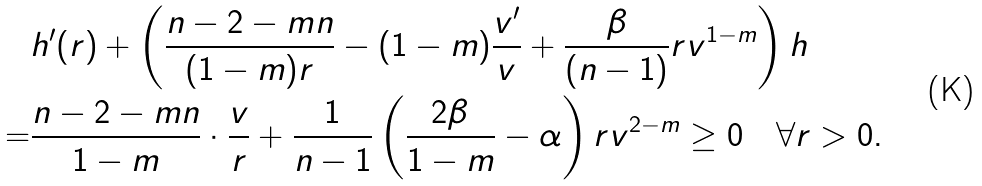<formula> <loc_0><loc_0><loc_500><loc_500>& h ^ { \prime } ( r ) + \left ( \frac { n - 2 - m n } { ( 1 - m ) r } - ( 1 - m ) \frac { v ^ { \prime } } { v } + \frac { \beta } { ( n - 1 ) } r v ^ { 1 - m } \right ) h \\ = & \frac { n - 2 - m n } { 1 - m } \cdot \frac { v } { r } + \frac { 1 } { n - 1 } \left ( \frac { 2 \beta } { 1 - m } - \alpha \right ) r v ^ { 2 - m } \geq 0 \quad \forall r > 0 .</formula> 